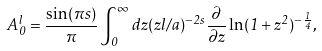Convert formula to latex. <formula><loc_0><loc_0><loc_500><loc_500>A _ { 0 } ^ { l } = \frac { \sin ( \pi s ) } { \pi } \int _ { 0 } ^ { \infty } d z ( z l / a ) ^ { - 2 s } \frac { \partial } { \partial z } \ln ( 1 + z ^ { 2 } ) ^ { - \frac { 1 } { 4 } } ,</formula> 